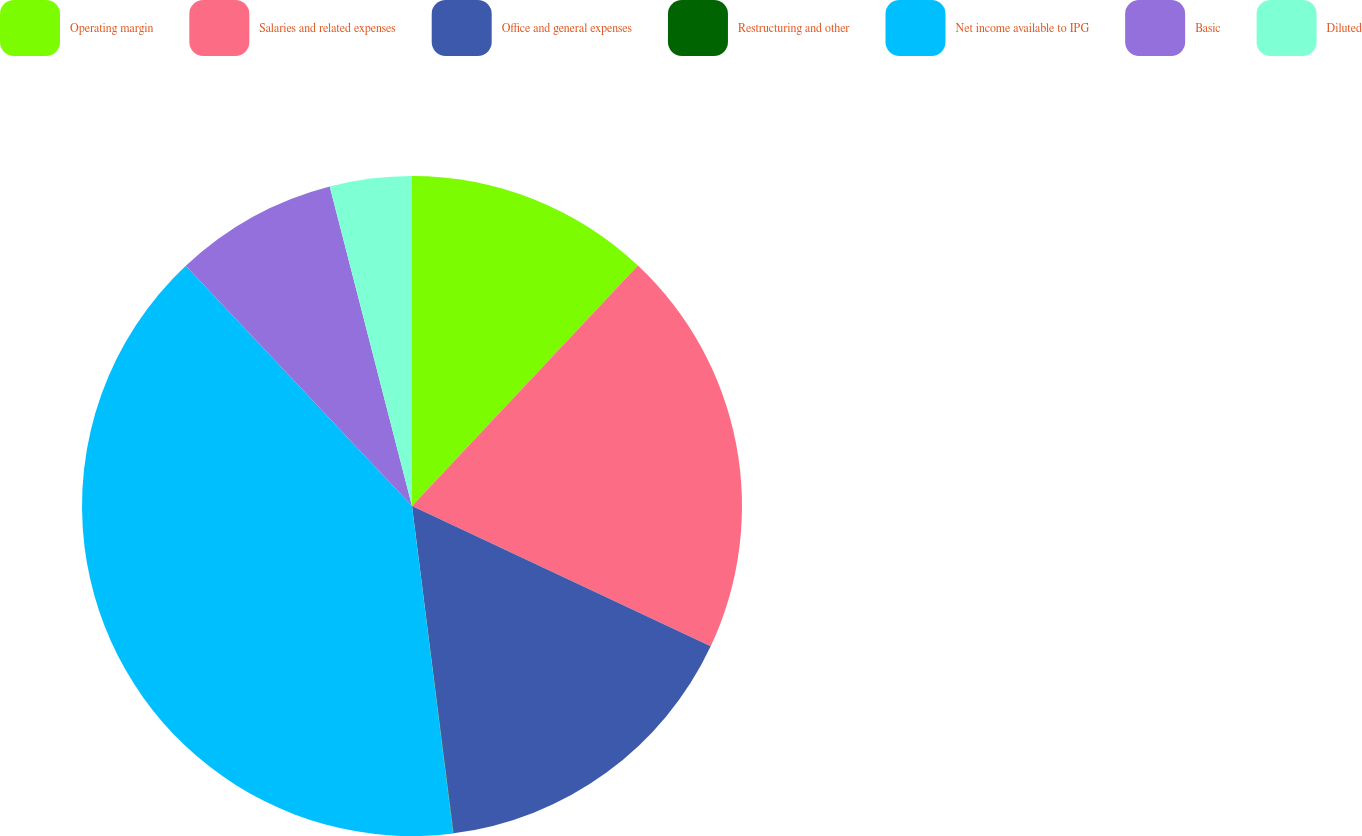<chart> <loc_0><loc_0><loc_500><loc_500><pie_chart><fcel>Operating margin<fcel>Salaries and related expenses<fcel>Office and general expenses<fcel>Restructuring and other<fcel>Net income available to IPG<fcel>Basic<fcel>Diluted<nl><fcel>12.0%<fcel>19.99%<fcel>16.0%<fcel>0.02%<fcel>39.97%<fcel>8.01%<fcel>4.01%<nl></chart> 